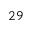<formula> <loc_0><loc_0><loc_500><loc_500>^ { 2 } 9</formula> 